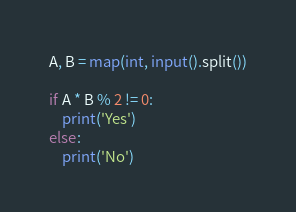<code> <loc_0><loc_0><loc_500><loc_500><_Python_>A, B = map(int, input().split())

if A * B % 2 != 0:
    print('Yes')
else:
    print('No')
</code> 